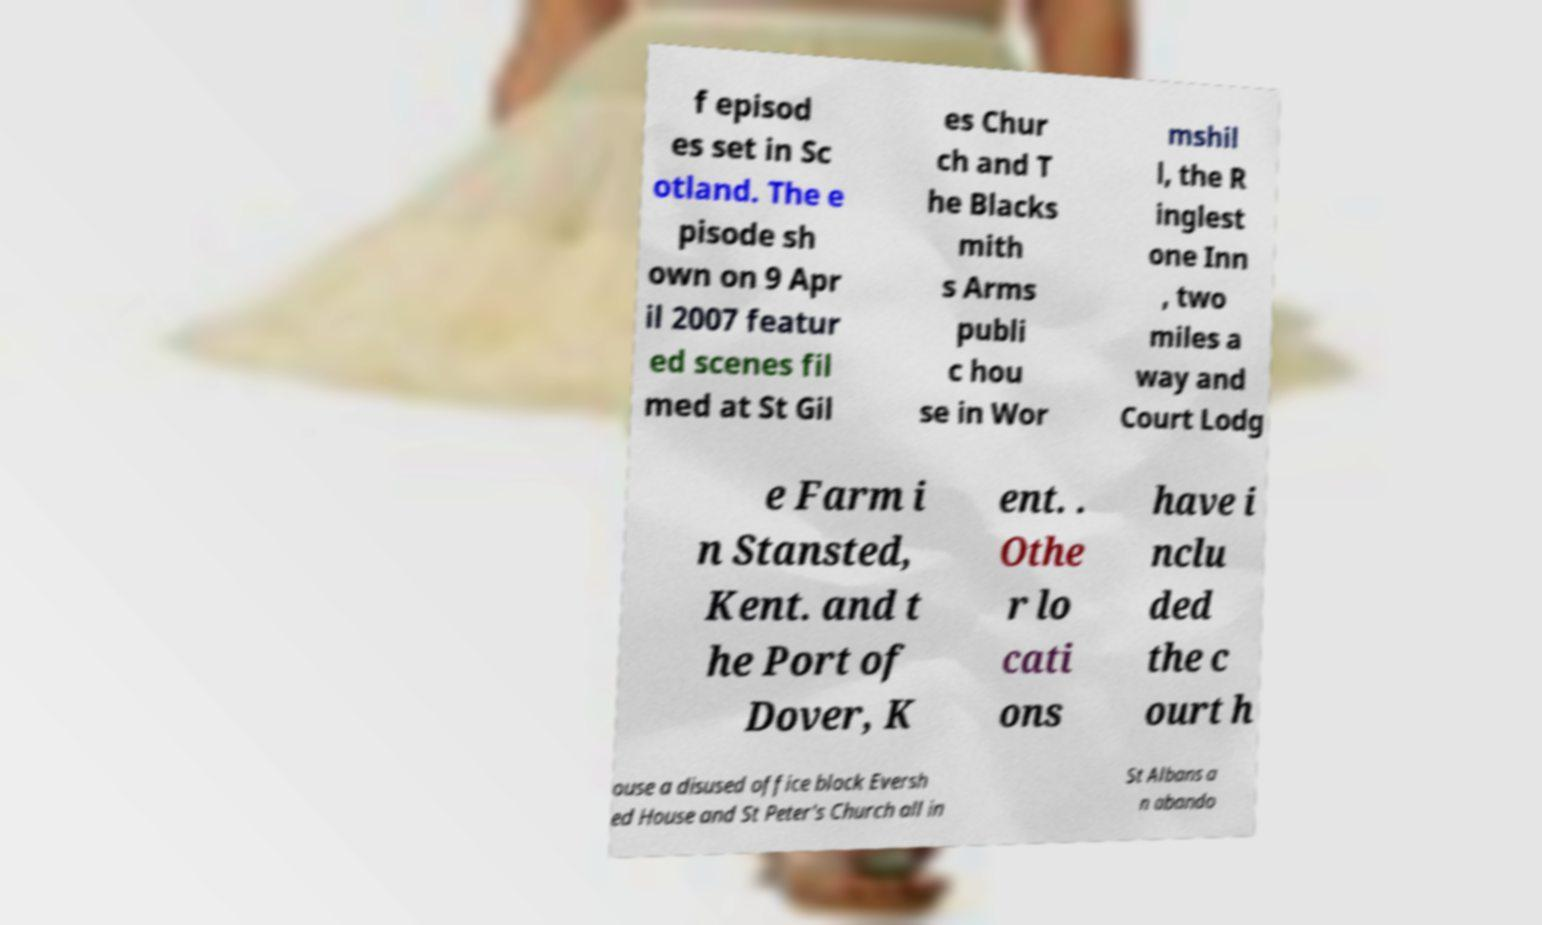Could you assist in decoding the text presented in this image and type it out clearly? f episod es set in Sc otland. The e pisode sh own on 9 Apr il 2007 featur ed scenes fil med at St Gil es Chur ch and T he Blacks mith s Arms publi c hou se in Wor mshil l, the R inglest one Inn , two miles a way and Court Lodg e Farm i n Stansted, Kent. and t he Port of Dover, K ent. . Othe r lo cati ons have i nclu ded the c ourt h ouse a disused office block Eversh ed House and St Peter's Church all in St Albans a n abando 